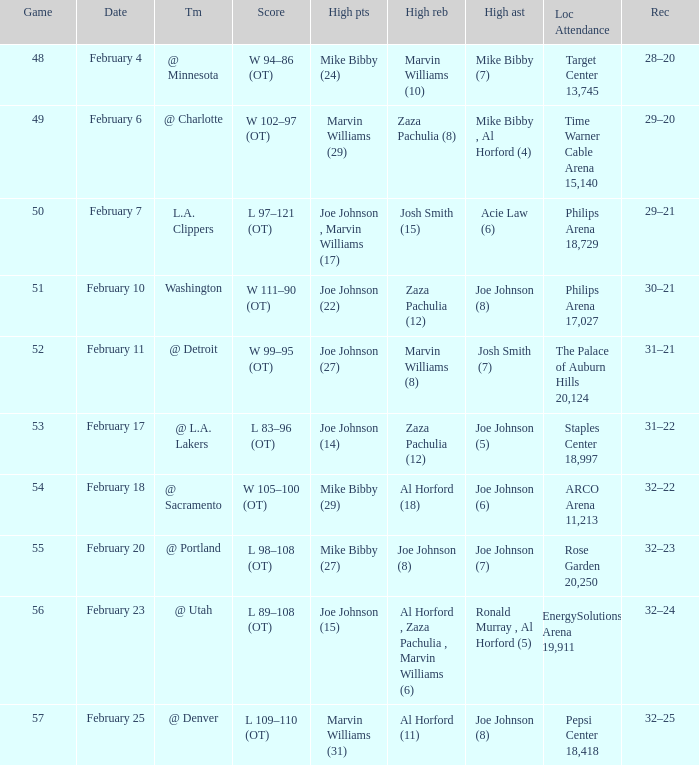How many high assists stats were maade on february 4 1.0. Parse the full table. {'header': ['Game', 'Date', 'Tm', 'Score', 'High pts', 'High reb', 'High ast', 'Loc Attendance', 'Rec'], 'rows': [['48', 'February 4', '@ Minnesota', 'W 94–86 (OT)', 'Mike Bibby (24)', 'Marvin Williams (10)', 'Mike Bibby (7)', 'Target Center 13,745', '28–20'], ['49', 'February 6', '@ Charlotte', 'W 102–97 (OT)', 'Marvin Williams (29)', 'Zaza Pachulia (8)', 'Mike Bibby , Al Horford (4)', 'Time Warner Cable Arena 15,140', '29–20'], ['50', 'February 7', 'L.A. Clippers', 'L 97–121 (OT)', 'Joe Johnson , Marvin Williams (17)', 'Josh Smith (15)', 'Acie Law (6)', 'Philips Arena 18,729', '29–21'], ['51', 'February 10', 'Washington', 'W 111–90 (OT)', 'Joe Johnson (22)', 'Zaza Pachulia (12)', 'Joe Johnson (8)', 'Philips Arena 17,027', '30–21'], ['52', 'February 11', '@ Detroit', 'W 99–95 (OT)', 'Joe Johnson (27)', 'Marvin Williams (8)', 'Josh Smith (7)', 'The Palace of Auburn Hills 20,124', '31–21'], ['53', 'February 17', '@ L.A. Lakers', 'L 83–96 (OT)', 'Joe Johnson (14)', 'Zaza Pachulia (12)', 'Joe Johnson (5)', 'Staples Center 18,997', '31–22'], ['54', 'February 18', '@ Sacramento', 'W 105–100 (OT)', 'Mike Bibby (29)', 'Al Horford (18)', 'Joe Johnson (6)', 'ARCO Arena 11,213', '32–22'], ['55', 'February 20', '@ Portland', 'L 98–108 (OT)', 'Mike Bibby (27)', 'Joe Johnson (8)', 'Joe Johnson (7)', 'Rose Garden 20,250', '32–23'], ['56', 'February 23', '@ Utah', 'L 89–108 (OT)', 'Joe Johnson (15)', 'Al Horford , Zaza Pachulia , Marvin Williams (6)', 'Ronald Murray , Al Horford (5)', 'EnergySolutions Arena 19,911', '32–24'], ['57', 'February 25', '@ Denver', 'L 109–110 (OT)', 'Marvin Williams (31)', 'Al Horford (11)', 'Joe Johnson (8)', 'Pepsi Center 18,418', '32–25']]} 